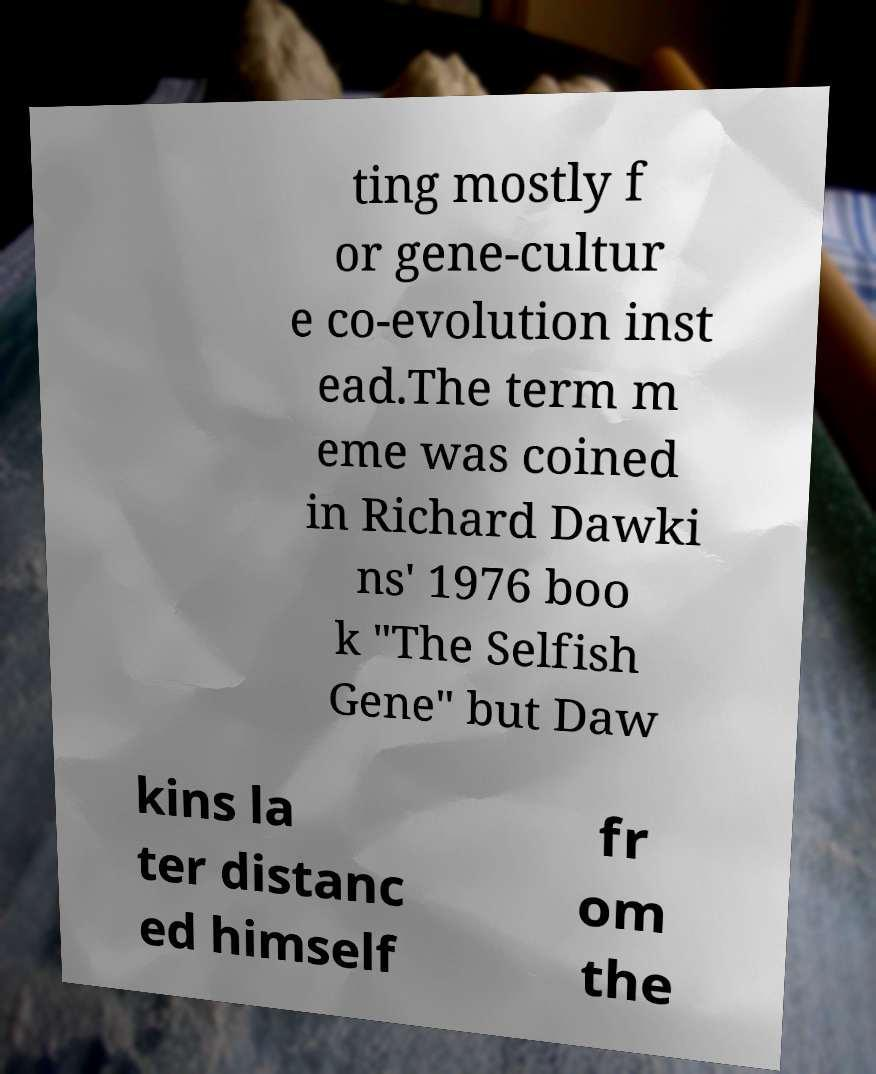I need the written content from this picture converted into text. Can you do that? ting mostly f or gene-cultur e co-evolution inst ead.The term m eme was coined in Richard Dawki ns' 1976 boo k "The Selfish Gene" but Daw kins la ter distanc ed himself fr om the 